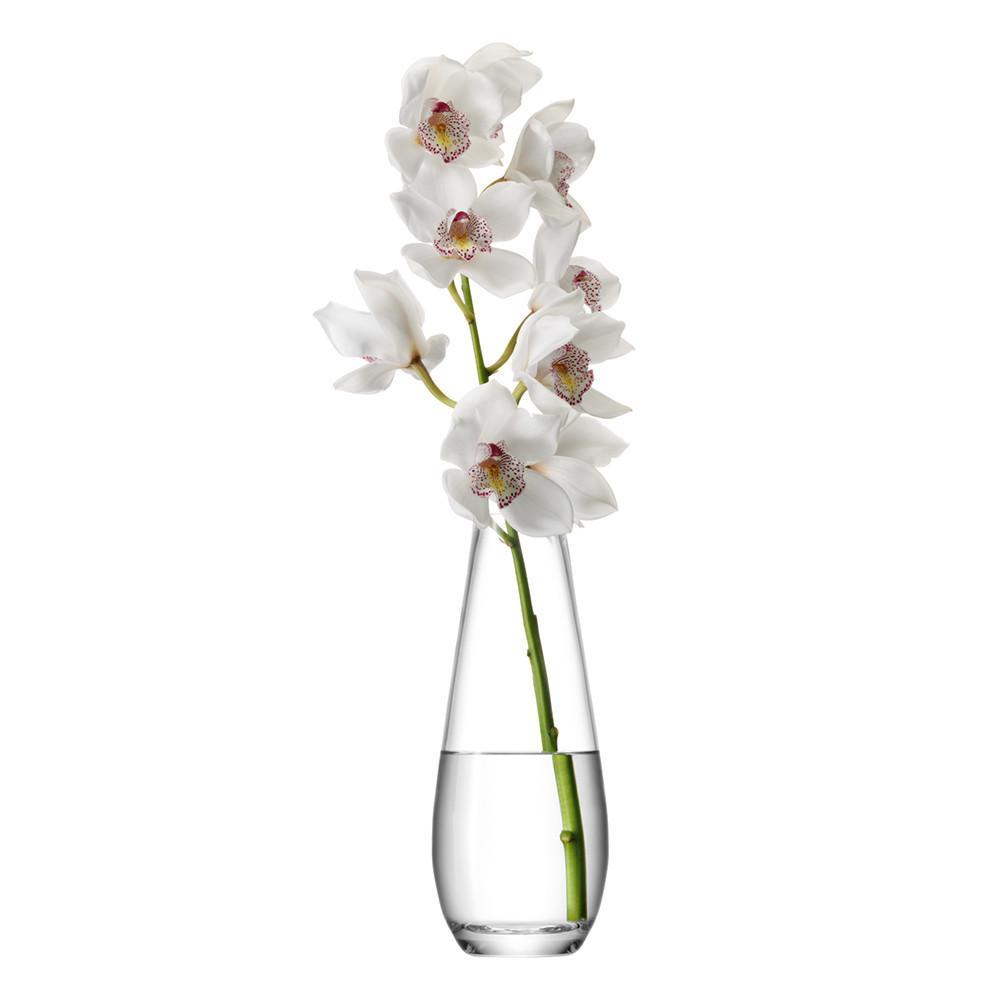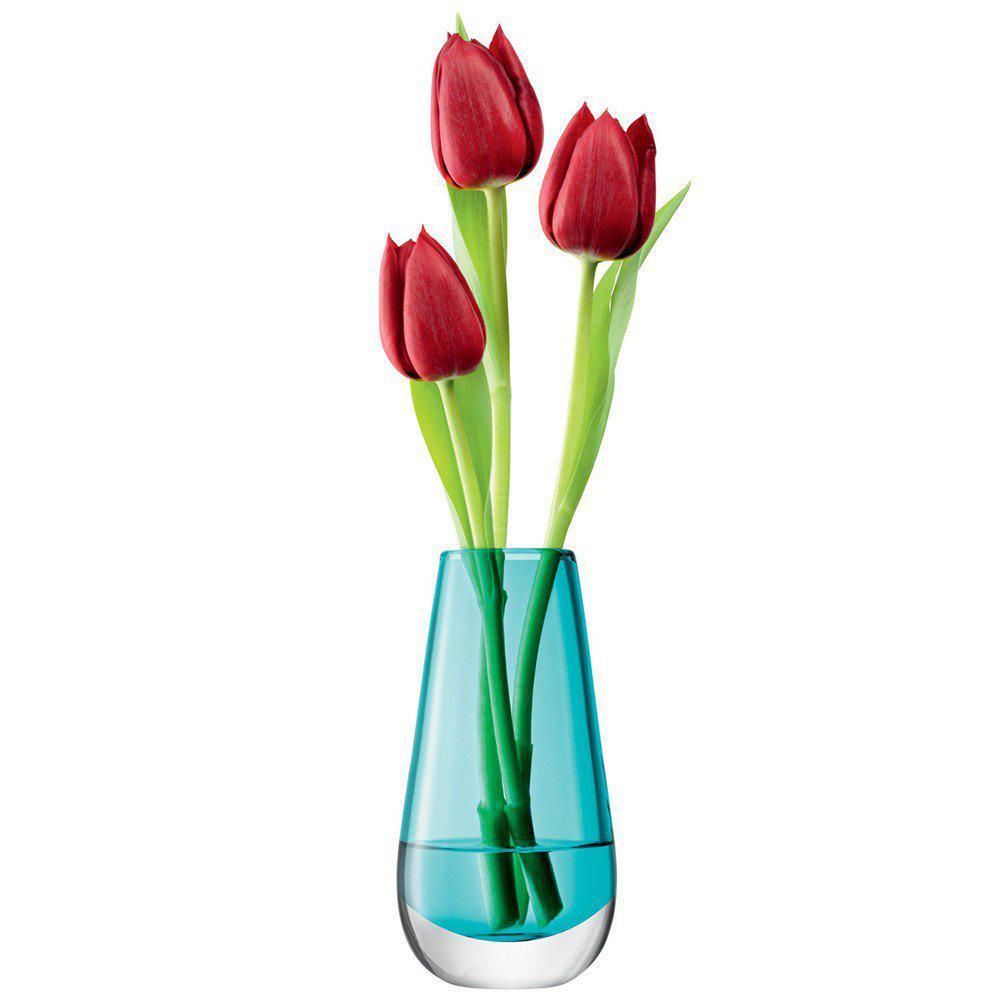The first image is the image on the left, the second image is the image on the right. For the images shown, is this caption "There are at most 3 tulips in a glass vase" true? Answer yes or no. Yes. The first image is the image on the left, the second image is the image on the right. Evaluate the accuracy of this statement regarding the images: "One of the images contains at least one vase that is completely opaque.". Is it true? Answer yes or no. No. 